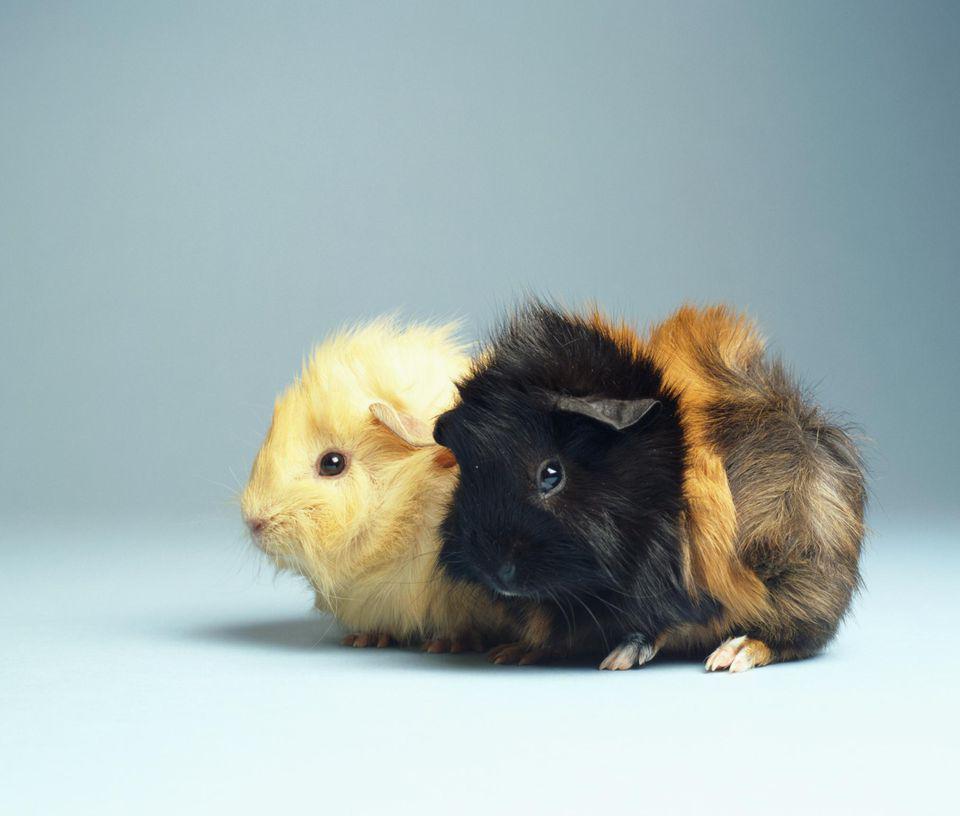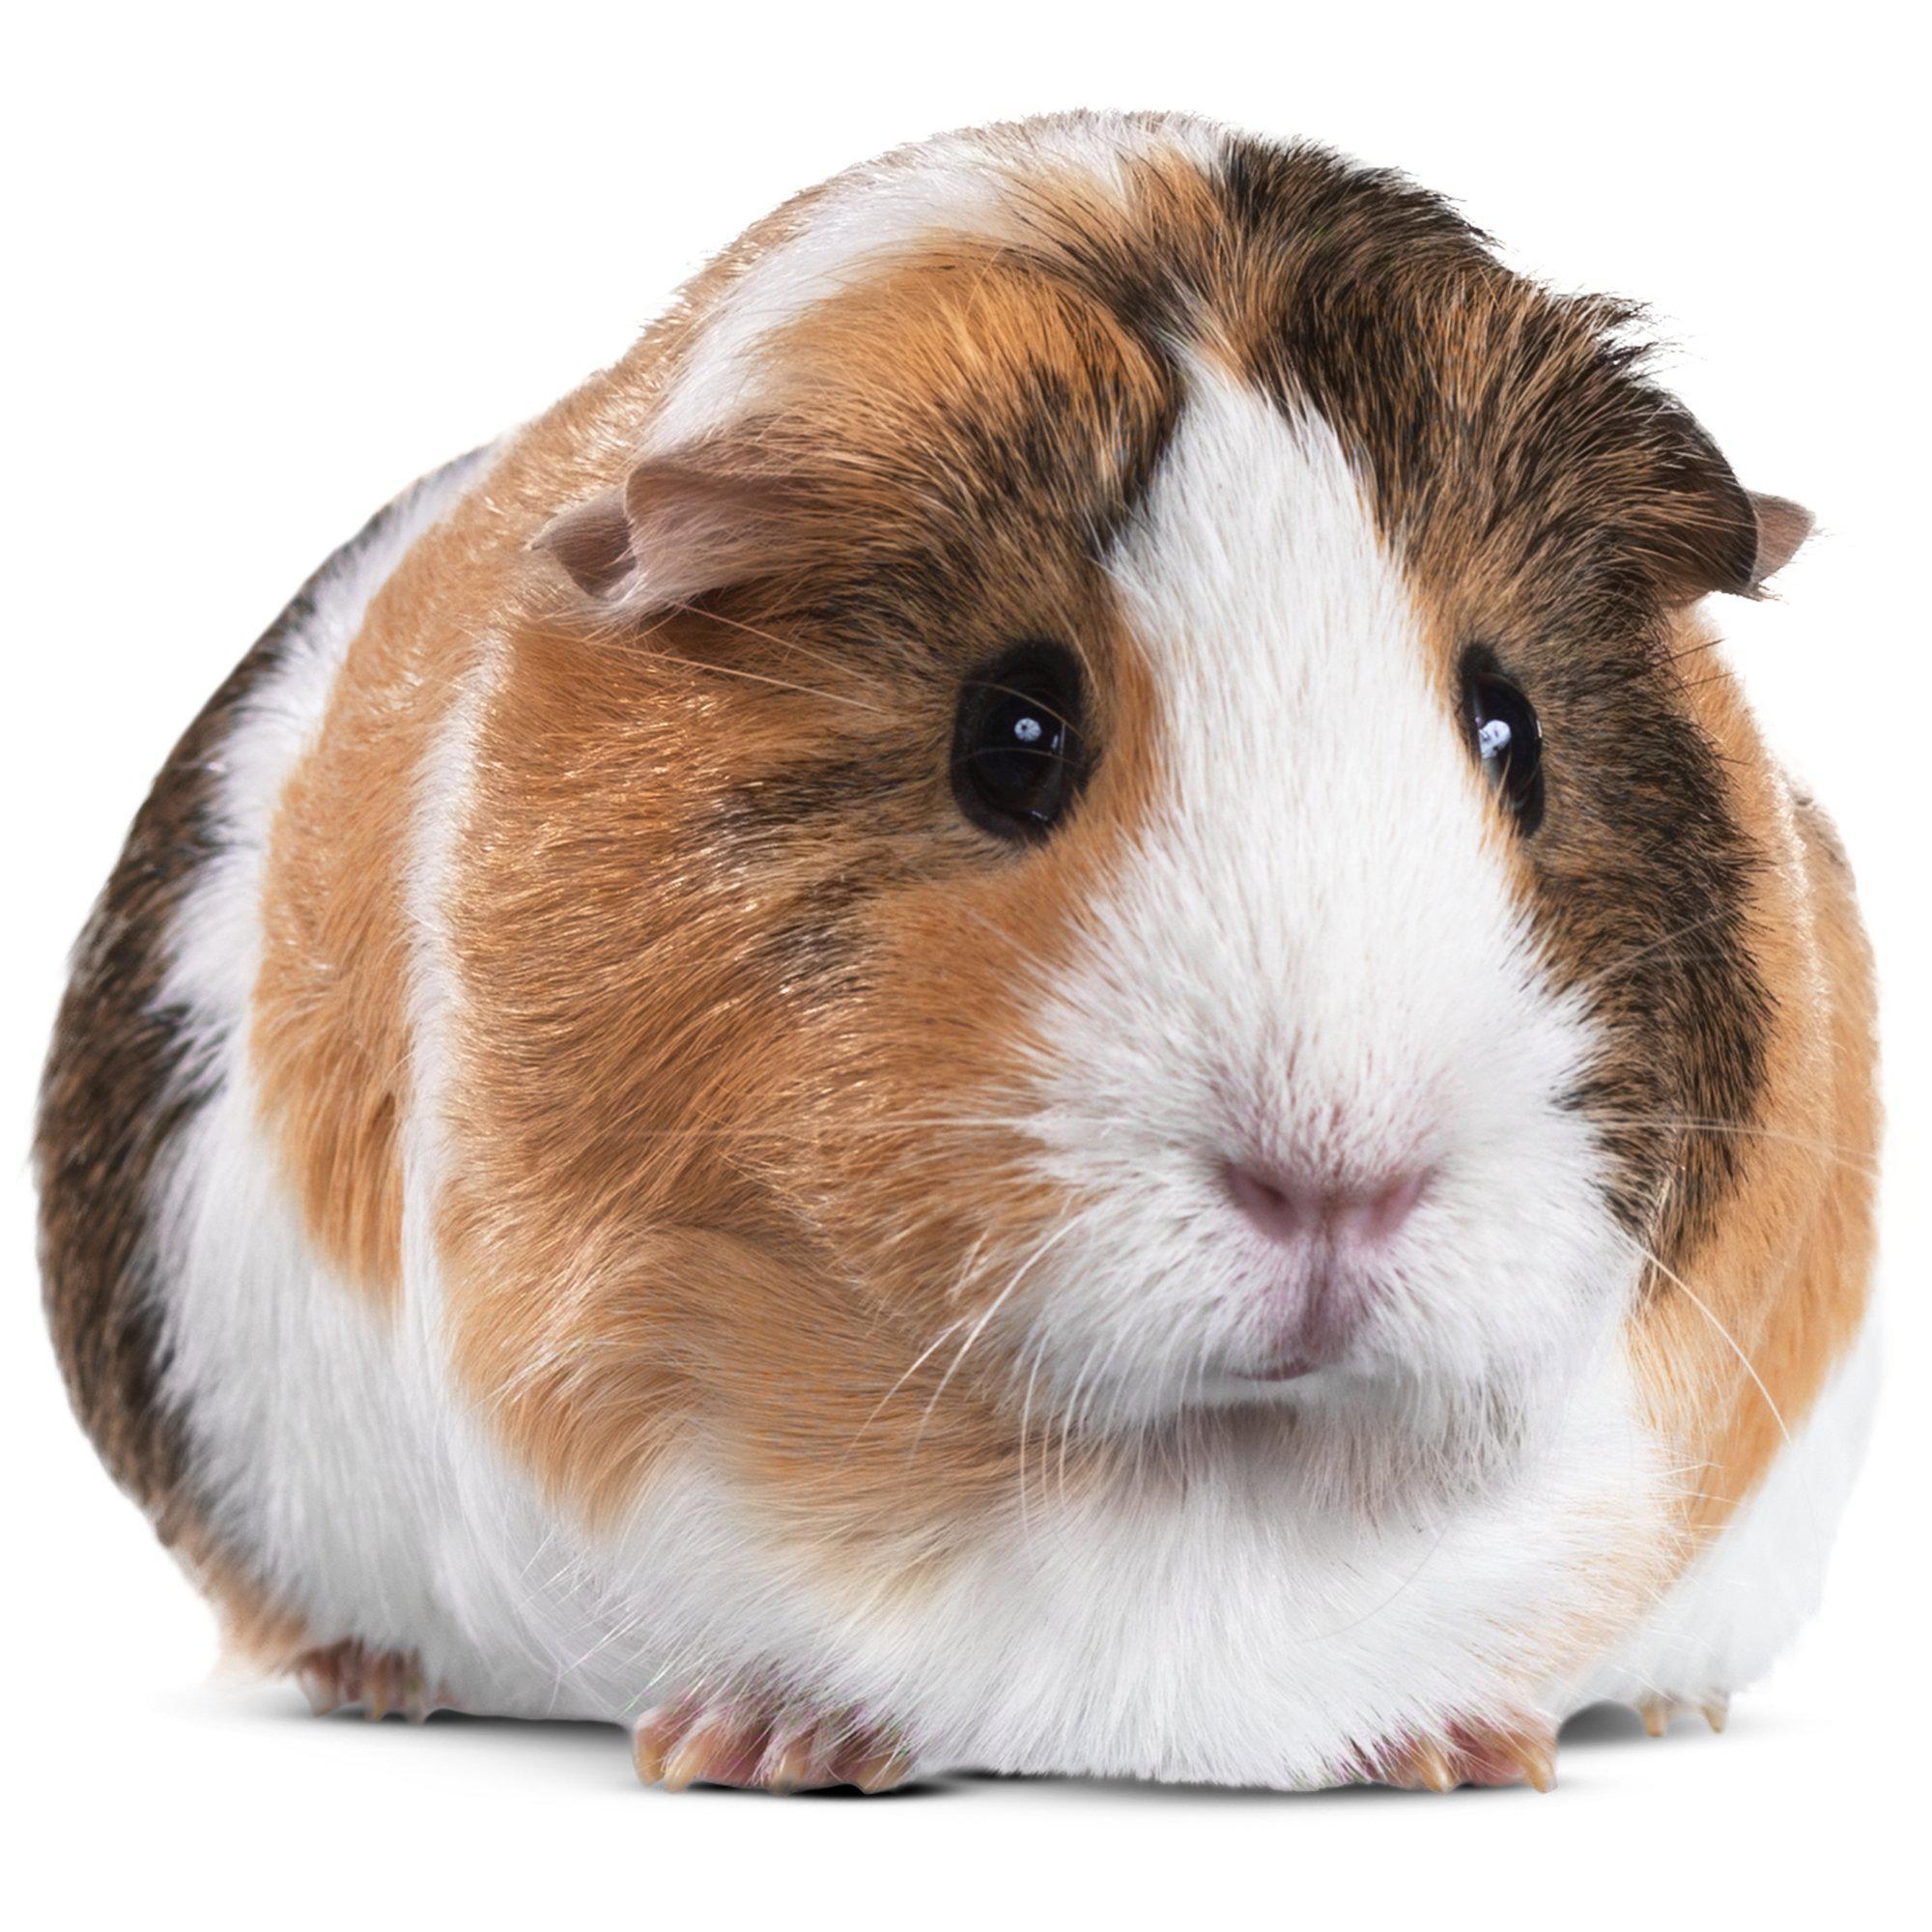The first image is the image on the left, the second image is the image on the right. For the images displayed, is the sentence "There are three hamsters." factually correct? Answer yes or no. Yes. The first image is the image on the left, the second image is the image on the right. Assess this claim about the two images: "there are exactly two animals in the image on the left". Correct or not? Answer yes or no. Yes. 